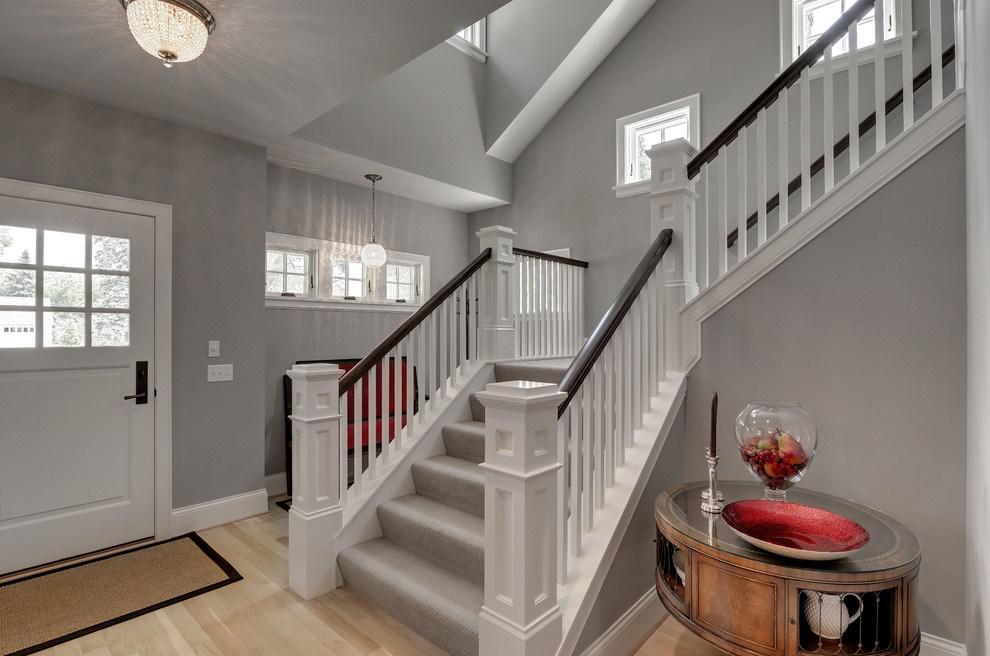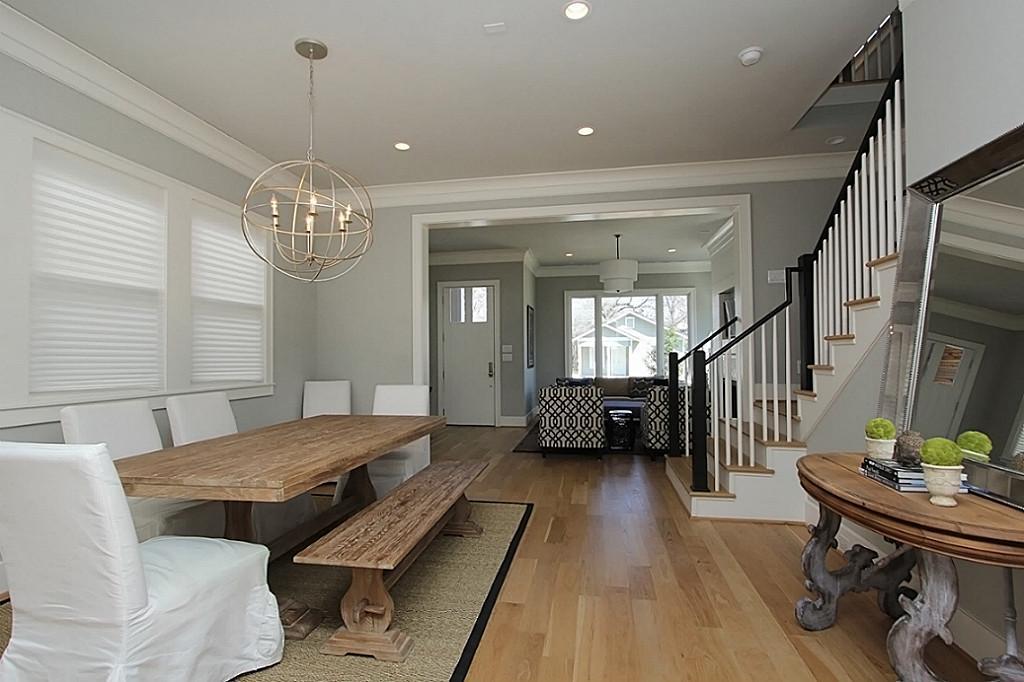The first image is the image on the left, the second image is the image on the right. Given the left and right images, does the statement "The left and right image contains the same number of staircases." hold true? Answer yes or no. Yes. 